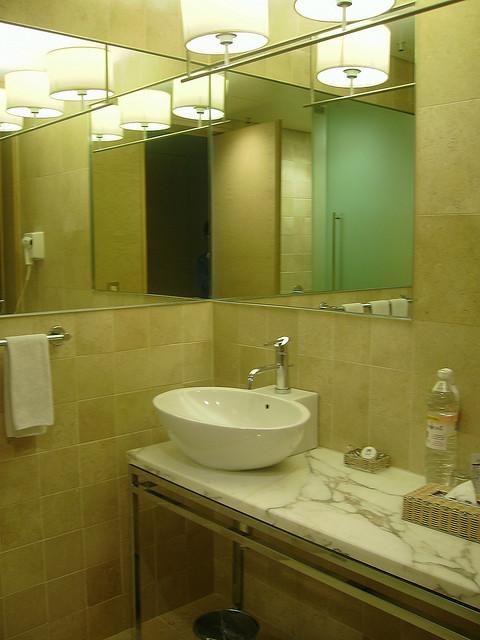What room is this?
Short answer required. Bathroom. How many mirrors are there?
Answer briefly. 2. Is there a towel hanging?
Answer briefly. Yes. What is the color of the sink?
Quick response, please. White. 